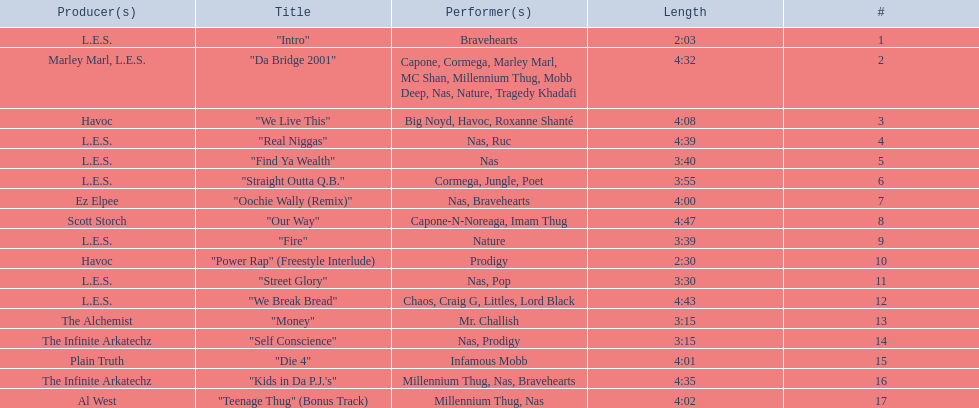What are the track lengths on the album? 2:03, 4:32, 4:08, 4:39, 3:40, 3:55, 4:00, 4:47, 3:39, 2:30, 3:30, 4:43, 3:15, 3:15, 4:01, 4:35, 4:02. What is the longest length? 4:47. 